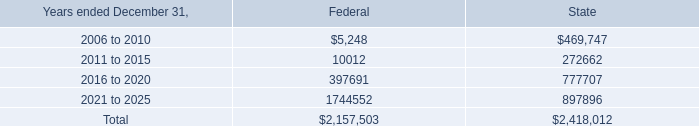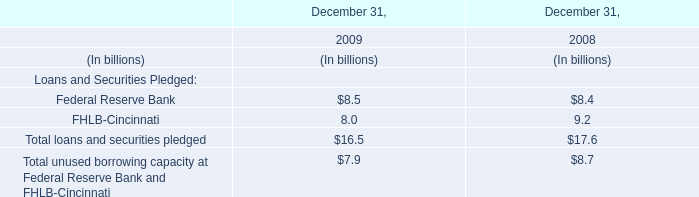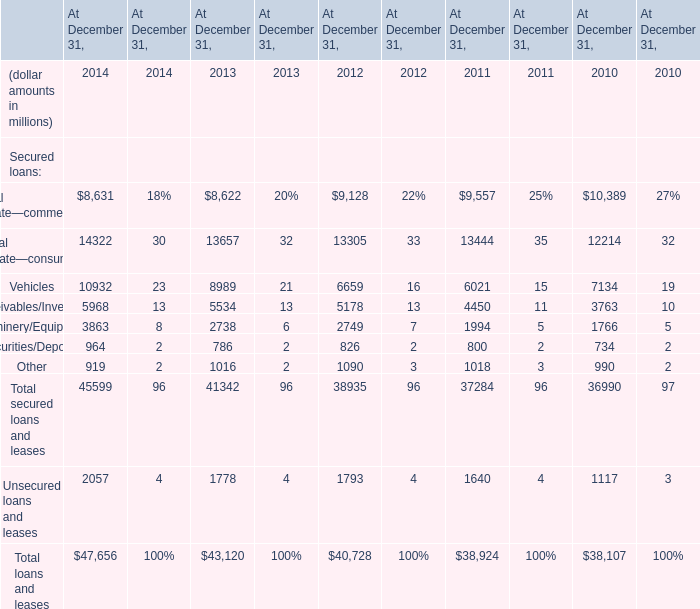what's the total amount of Real estate—consumer of At December 31, 2014, 2016 to 2020 of State, and Receivables/Inventory of At December 31, 2013 ? 
Computations: ((14322.0 + 777707.0) + 5534.0)
Answer: 797563.0. 